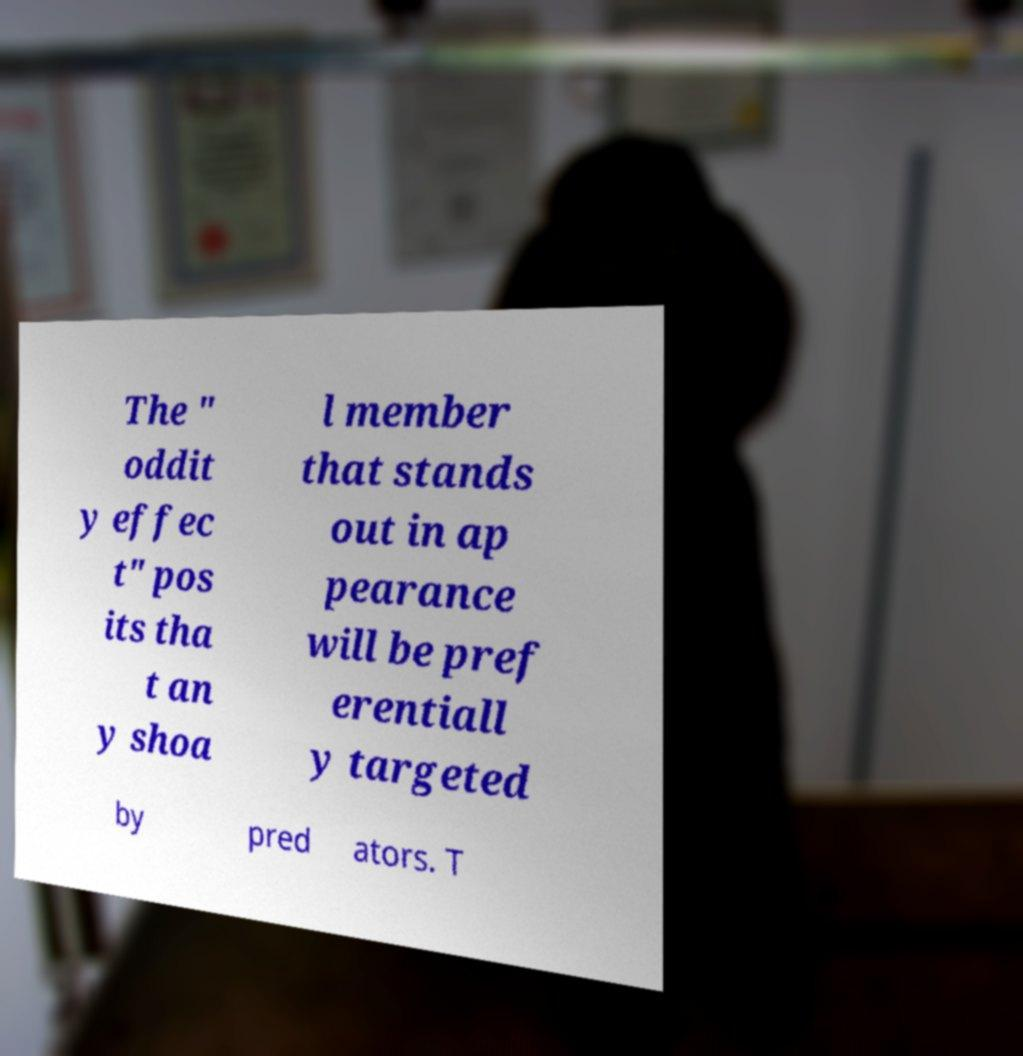Can you read and provide the text displayed in the image?This photo seems to have some interesting text. Can you extract and type it out for me? The " oddit y effec t" pos its tha t an y shoa l member that stands out in ap pearance will be pref erentiall y targeted by pred ators. T 